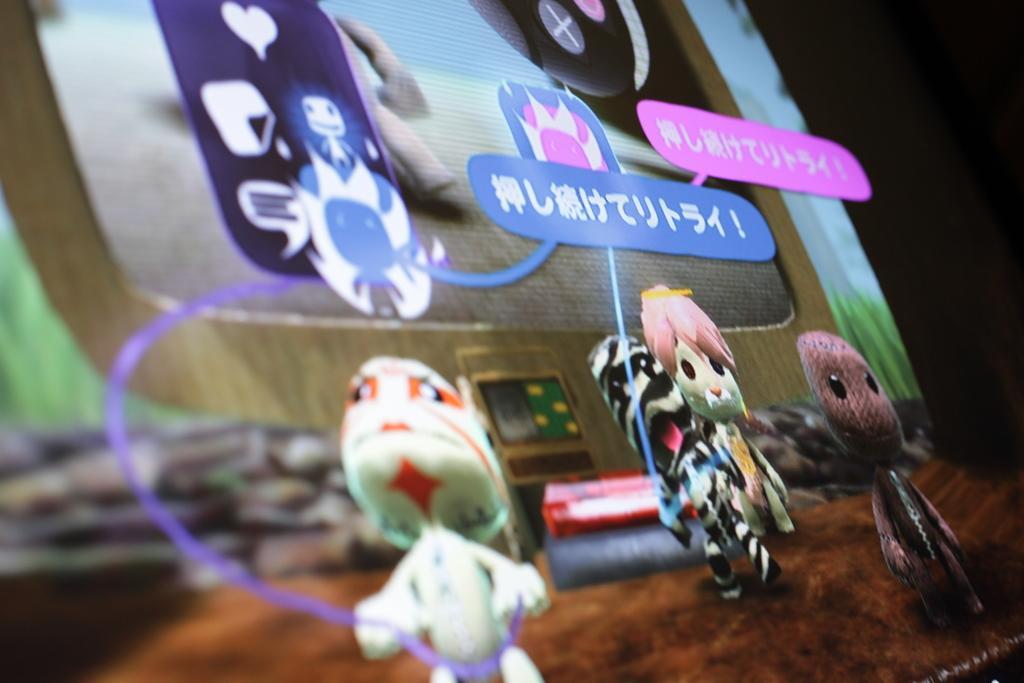Could you give a brief overview of what you see in this image? This is an animated image where we can see toy images, some edited text and icons. The left side of the image is slightly blurred. 